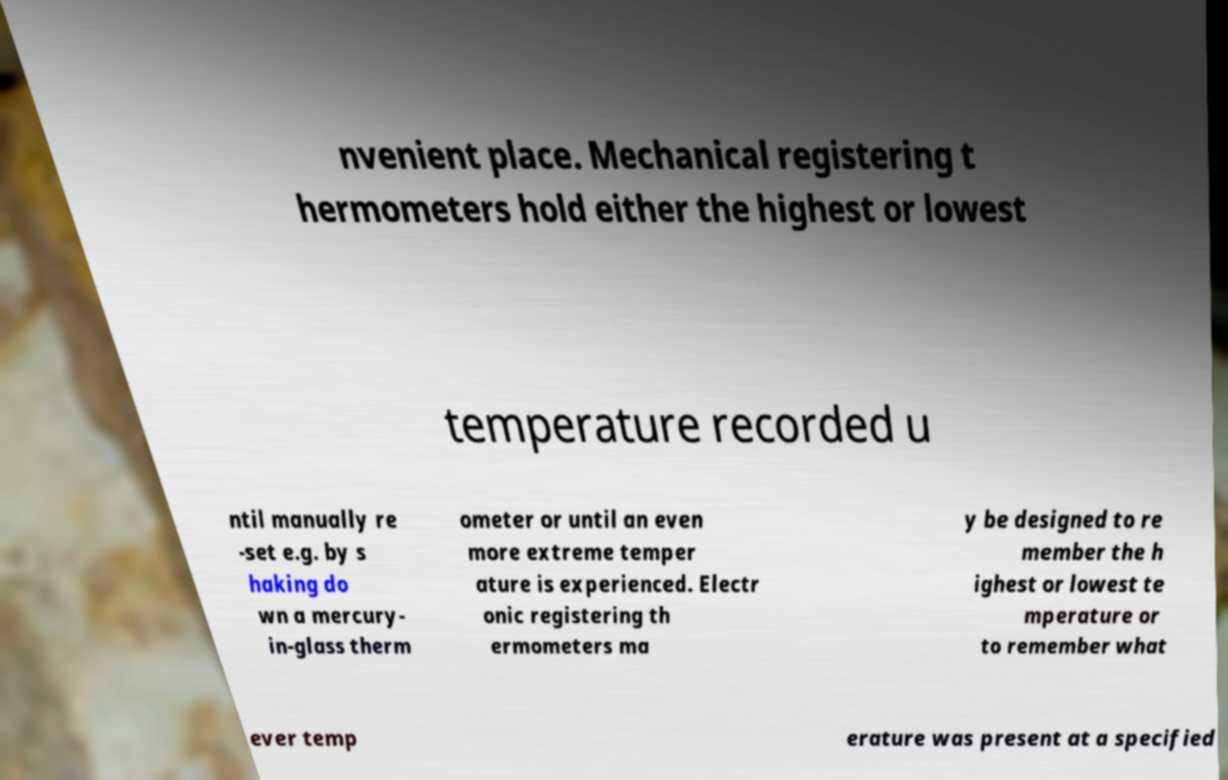Please read and relay the text visible in this image. What does it say? nvenient place. Mechanical registering t hermometers hold either the highest or lowest temperature recorded u ntil manually re -set e.g. by s haking do wn a mercury- in-glass therm ometer or until an even more extreme temper ature is experienced. Electr onic registering th ermometers ma y be designed to re member the h ighest or lowest te mperature or to remember what ever temp erature was present at a specified 